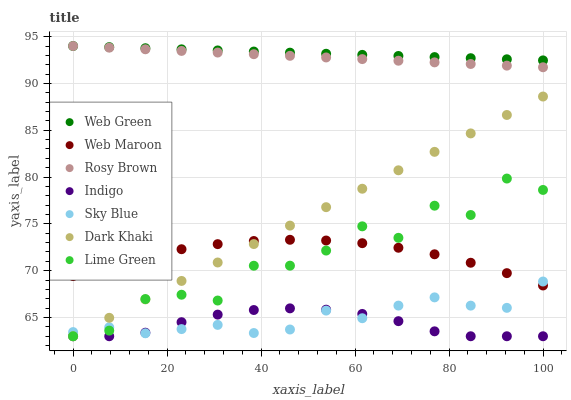Does Indigo have the minimum area under the curve?
Answer yes or no. Yes. Does Web Green have the maximum area under the curve?
Answer yes or no. Yes. Does Rosy Brown have the minimum area under the curve?
Answer yes or no. No. Does Rosy Brown have the maximum area under the curve?
Answer yes or no. No. Is Dark Khaki the smoothest?
Answer yes or no. Yes. Is Lime Green the roughest?
Answer yes or no. Yes. Is Rosy Brown the smoothest?
Answer yes or no. No. Is Rosy Brown the roughest?
Answer yes or no. No. Does Indigo have the lowest value?
Answer yes or no. Yes. Does Rosy Brown have the lowest value?
Answer yes or no. No. Does Web Green have the highest value?
Answer yes or no. Yes. Does Web Maroon have the highest value?
Answer yes or no. No. Is Web Maroon less than Rosy Brown?
Answer yes or no. Yes. Is Web Green greater than Indigo?
Answer yes or no. Yes. Does Indigo intersect Dark Khaki?
Answer yes or no. Yes. Is Indigo less than Dark Khaki?
Answer yes or no. No. Is Indigo greater than Dark Khaki?
Answer yes or no. No. Does Web Maroon intersect Rosy Brown?
Answer yes or no. No. 